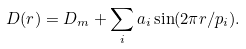<formula> <loc_0><loc_0><loc_500><loc_500>D ( r ) = D _ { m } + \sum _ { i } a _ { i } \sin ( 2 \pi r / p _ { i } ) .</formula> 